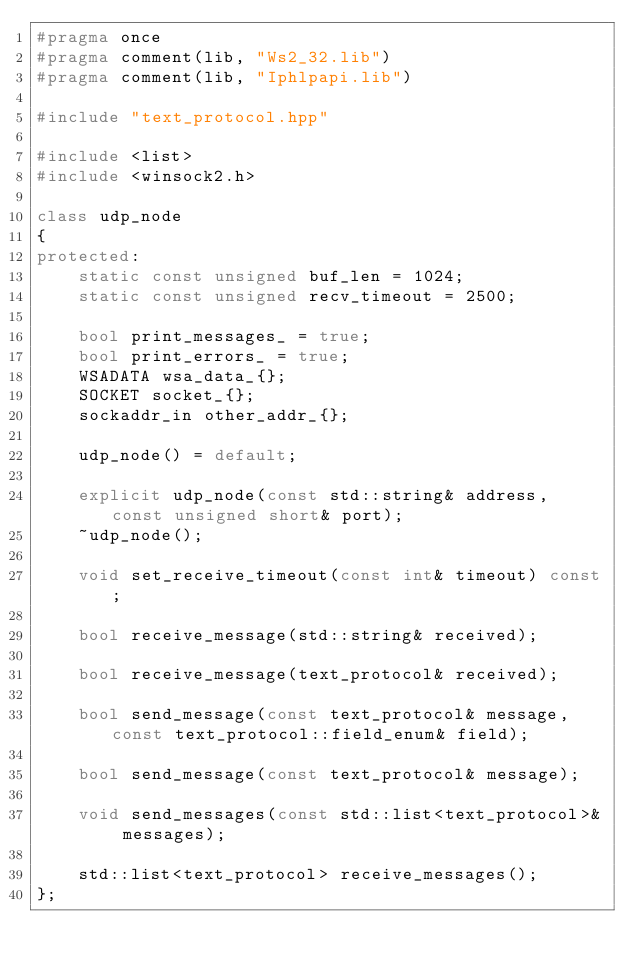<code> <loc_0><loc_0><loc_500><loc_500><_C++_>#pragma once
#pragma comment(lib, "Ws2_32.lib")
#pragma comment(lib, "Iphlpapi.lib")

#include "text_protocol.hpp"

#include <list>
#include <winsock2.h>

class udp_node
{
protected:
	static const unsigned buf_len = 1024;
	static const unsigned recv_timeout = 2500;

	bool print_messages_ = true;
	bool print_errors_ = true;
	WSADATA wsa_data_{};
	SOCKET socket_{};
	sockaddr_in other_addr_{};

	udp_node() = default;

	explicit udp_node(const std::string& address, const unsigned short& port);
	~udp_node();

	void set_receive_timeout(const int& timeout) const;

	bool receive_message(std::string& received);

	bool receive_message(text_protocol& received);

	bool send_message(const text_protocol& message, const text_protocol::field_enum& field);

	bool send_message(const text_protocol& message);

	void send_messages(const std::list<text_protocol>& messages);

	std::list<text_protocol> receive_messages();
};
</code> 